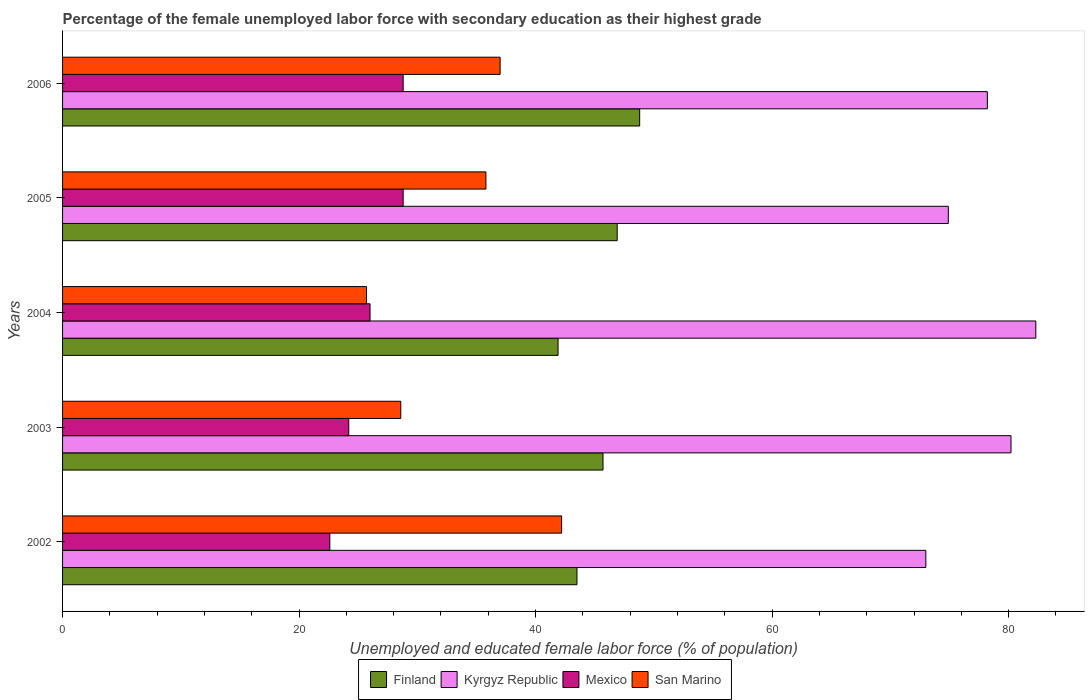How many different coloured bars are there?
Give a very brief answer. 4. How many groups of bars are there?
Offer a terse response. 5. Are the number of bars per tick equal to the number of legend labels?
Ensure brevity in your answer.  Yes. Are the number of bars on each tick of the Y-axis equal?
Provide a succinct answer. Yes. How many bars are there on the 5th tick from the bottom?
Offer a terse response. 4. What is the percentage of the unemployed female labor force with secondary education in Mexico in 2006?
Give a very brief answer. 28.8. Across all years, what is the maximum percentage of the unemployed female labor force with secondary education in San Marino?
Offer a very short reply. 42.2. Across all years, what is the minimum percentage of the unemployed female labor force with secondary education in San Marino?
Provide a short and direct response. 25.7. In which year was the percentage of the unemployed female labor force with secondary education in Finland minimum?
Keep it short and to the point. 2004. What is the total percentage of the unemployed female labor force with secondary education in Kyrgyz Republic in the graph?
Give a very brief answer. 388.6. What is the difference between the percentage of the unemployed female labor force with secondary education in Kyrgyz Republic in 2002 and that in 2005?
Your answer should be very brief. -1.9. What is the difference between the percentage of the unemployed female labor force with secondary education in Mexico in 2004 and the percentage of the unemployed female labor force with secondary education in San Marino in 2005?
Make the answer very short. -9.8. What is the average percentage of the unemployed female labor force with secondary education in Mexico per year?
Keep it short and to the point. 26.08. In the year 2004, what is the difference between the percentage of the unemployed female labor force with secondary education in Mexico and percentage of the unemployed female labor force with secondary education in San Marino?
Provide a succinct answer. 0.3. What is the ratio of the percentage of the unemployed female labor force with secondary education in Mexico in 2004 to that in 2005?
Offer a terse response. 0.9. Is the difference between the percentage of the unemployed female labor force with secondary education in Mexico in 2004 and 2006 greater than the difference between the percentage of the unemployed female labor force with secondary education in San Marino in 2004 and 2006?
Offer a terse response. Yes. What is the difference between the highest and the lowest percentage of the unemployed female labor force with secondary education in Mexico?
Provide a short and direct response. 6.2. In how many years, is the percentage of the unemployed female labor force with secondary education in Kyrgyz Republic greater than the average percentage of the unemployed female labor force with secondary education in Kyrgyz Republic taken over all years?
Ensure brevity in your answer.  3. Is it the case that in every year, the sum of the percentage of the unemployed female labor force with secondary education in Kyrgyz Republic and percentage of the unemployed female labor force with secondary education in San Marino is greater than the sum of percentage of the unemployed female labor force with secondary education in Mexico and percentage of the unemployed female labor force with secondary education in Finland?
Offer a terse response. Yes. What does the 3rd bar from the top in 2003 represents?
Keep it short and to the point. Kyrgyz Republic. What does the 3rd bar from the bottom in 2002 represents?
Provide a succinct answer. Mexico. How many bars are there?
Ensure brevity in your answer.  20. How many years are there in the graph?
Provide a succinct answer. 5. Are the values on the major ticks of X-axis written in scientific E-notation?
Offer a very short reply. No. Does the graph contain any zero values?
Offer a terse response. No. Does the graph contain grids?
Offer a very short reply. No. How many legend labels are there?
Ensure brevity in your answer.  4. How are the legend labels stacked?
Make the answer very short. Horizontal. What is the title of the graph?
Your answer should be compact. Percentage of the female unemployed labor force with secondary education as their highest grade. Does "Bermuda" appear as one of the legend labels in the graph?
Make the answer very short. No. What is the label or title of the X-axis?
Offer a terse response. Unemployed and educated female labor force (% of population). What is the label or title of the Y-axis?
Keep it short and to the point. Years. What is the Unemployed and educated female labor force (% of population) of Finland in 2002?
Provide a short and direct response. 43.5. What is the Unemployed and educated female labor force (% of population) in Kyrgyz Republic in 2002?
Ensure brevity in your answer.  73. What is the Unemployed and educated female labor force (% of population) in Mexico in 2002?
Ensure brevity in your answer.  22.6. What is the Unemployed and educated female labor force (% of population) of San Marino in 2002?
Make the answer very short. 42.2. What is the Unemployed and educated female labor force (% of population) in Finland in 2003?
Provide a short and direct response. 45.7. What is the Unemployed and educated female labor force (% of population) in Kyrgyz Republic in 2003?
Give a very brief answer. 80.2. What is the Unemployed and educated female labor force (% of population) in Mexico in 2003?
Make the answer very short. 24.2. What is the Unemployed and educated female labor force (% of population) in San Marino in 2003?
Offer a very short reply. 28.6. What is the Unemployed and educated female labor force (% of population) of Finland in 2004?
Your answer should be compact. 41.9. What is the Unemployed and educated female labor force (% of population) in Kyrgyz Republic in 2004?
Offer a very short reply. 82.3. What is the Unemployed and educated female labor force (% of population) of San Marino in 2004?
Give a very brief answer. 25.7. What is the Unemployed and educated female labor force (% of population) in Finland in 2005?
Give a very brief answer. 46.9. What is the Unemployed and educated female labor force (% of population) in Kyrgyz Republic in 2005?
Your answer should be compact. 74.9. What is the Unemployed and educated female labor force (% of population) of Mexico in 2005?
Your answer should be compact. 28.8. What is the Unemployed and educated female labor force (% of population) in San Marino in 2005?
Make the answer very short. 35.8. What is the Unemployed and educated female labor force (% of population) in Finland in 2006?
Your answer should be compact. 48.8. What is the Unemployed and educated female labor force (% of population) in Kyrgyz Republic in 2006?
Give a very brief answer. 78.2. What is the Unemployed and educated female labor force (% of population) of Mexico in 2006?
Make the answer very short. 28.8. What is the Unemployed and educated female labor force (% of population) in San Marino in 2006?
Your answer should be very brief. 37. Across all years, what is the maximum Unemployed and educated female labor force (% of population) of Finland?
Your response must be concise. 48.8. Across all years, what is the maximum Unemployed and educated female labor force (% of population) of Kyrgyz Republic?
Your answer should be compact. 82.3. Across all years, what is the maximum Unemployed and educated female labor force (% of population) of Mexico?
Offer a terse response. 28.8. Across all years, what is the maximum Unemployed and educated female labor force (% of population) in San Marino?
Your answer should be compact. 42.2. Across all years, what is the minimum Unemployed and educated female labor force (% of population) in Finland?
Make the answer very short. 41.9. Across all years, what is the minimum Unemployed and educated female labor force (% of population) of Kyrgyz Republic?
Provide a succinct answer. 73. Across all years, what is the minimum Unemployed and educated female labor force (% of population) in Mexico?
Offer a terse response. 22.6. Across all years, what is the minimum Unemployed and educated female labor force (% of population) of San Marino?
Provide a short and direct response. 25.7. What is the total Unemployed and educated female labor force (% of population) in Finland in the graph?
Give a very brief answer. 226.8. What is the total Unemployed and educated female labor force (% of population) of Kyrgyz Republic in the graph?
Make the answer very short. 388.6. What is the total Unemployed and educated female labor force (% of population) of Mexico in the graph?
Your answer should be very brief. 130.4. What is the total Unemployed and educated female labor force (% of population) in San Marino in the graph?
Keep it short and to the point. 169.3. What is the difference between the Unemployed and educated female labor force (% of population) in Finland in 2002 and that in 2003?
Provide a succinct answer. -2.2. What is the difference between the Unemployed and educated female labor force (% of population) of Kyrgyz Republic in 2002 and that in 2003?
Keep it short and to the point. -7.2. What is the difference between the Unemployed and educated female labor force (% of population) in Mexico in 2002 and that in 2003?
Offer a very short reply. -1.6. What is the difference between the Unemployed and educated female labor force (% of population) of Finland in 2002 and that in 2004?
Your response must be concise. 1.6. What is the difference between the Unemployed and educated female labor force (% of population) of San Marino in 2002 and that in 2004?
Offer a very short reply. 16.5. What is the difference between the Unemployed and educated female labor force (% of population) of Finland in 2002 and that in 2005?
Keep it short and to the point. -3.4. What is the difference between the Unemployed and educated female labor force (% of population) of Kyrgyz Republic in 2002 and that in 2005?
Offer a very short reply. -1.9. What is the difference between the Unemployed and educated female labor force (% of population) in Mexico in 2002 and that in 2005?
Give a very brief answer. -6.2. What is the difference between the Unemployed and educated female labor force (% of population) of San Marino in 2002 and that in 2005?
Give a very brief answer. 6.4. What is the difference between the Unemployed and educated female labor force (% of population) in Finland in 2002 and that in 2006?
Provide a succinct answer. -5.3. What is the difference between the Unemployed and educated female labor force (% of population) of Kyrgyz Republic in 2002 and that in 2006?
Offer a very short reply. -5.2. What is the difference between the Unemployed and educated female labor force (% of population) in San Marino in 2002 and that in 2006?
Your response must be concise. 5.2. What is the difference between the Unemployed and educated female labor force (% of population) in Finland in 2003 and that in 2005?
Provide a short and direct response. -1.2. What is the difference between the Unemployed and educated female labor force (% of population) in Mexico in 2003 and that in 2005?
Provide a short and direct response. -4.6. What is the difference between the Unemployed and educated female labor force (% of population) of Mexico in 2003 and that in 2006?
Make the answer very short. -4.6. What is the difference between the Unemployed and educated female labor force (% of population) in Finland in 2004 and that in 2005?
Provide a succinct answer. -5. What is the difference between the Unemployed and educated female labor force (% of population) of Kyrgyz Republic in 2004 and that in 2005?
Your response must be concise. 7.4. What is the difference between the Unemployed and educated female labor force (% of population) in Finland in 2004 and that in 2006?
Your answer should be very brief. -6.9. What is the difference between the Unemployed and educated female labor force (% of population) of Kyrgyz Republic in 2004 and that in 2006?
Your response must be concise. 4.1. What is the difference between the Unemployed and educated female labor force (% of population) of Mexico in 2004 and that in 2006?
Make the answer very short. -2.8. What is the difference between the Unemployed and educated female labor force (% of population) of San Marino in 2004 and that in 2006?
Provide a succinct answer. -11.3. What is the difference between the Unemployed and educated female labor force (% of population) in Kyrgyz Republic in 2005 and that in 2006?
Offer a very short reply. -3.3. What is the difference between the Unemployed and educated female labor force (% of population) of Mexico in 2005 and that in 2006?
Your answer should be very brief. 0. What is the difference between the Unemployed and educated female labor force (% of population) of Finland in 2002 and the Unemployed and educated female labor force (% of population) of Kyrgyz Republic in 2003?
Offer a terse response. -36.7. What is the difference between the Unemployed and educated female labor force (% of population) in Finland in 2002 and the Unemployed and educated female labor force (% of population) in Mexico in 2003?
Make the answer very short. 19.3. What is the difference between the Unemployed and educated female labor force (% of population) of Kyrgyz Republic in 2002 and the Unemployed and educated female labor force (% of population) of Mexico in 2003?
Keep it short and to the point. 48.8. What is the difference between the Unemployed and educated female labor force (% of population) of Kyrgyz Republic in 2002 and the Unemployed and educated female labor force (% of population) of San Marino in 2003?
Your answer should be compact. 44.4. What is the difference between the Unemployed and educated female labor force (% of population) of Mexico in 2002 and the Unemployed and educated female labor force (% of population) of San Marino in 2003?
Provide a succinct answer. -6. What is the difference between the Unemployed and educated female labor force (% of population) of Finland in 2002 and the Unemployed and educated female labor force (% of population) of Kyrgyz Republic in 2004?
Your answer should be compact. -38.8. What is the difference between the Unemployed and educated female labor force (% of population) of Finland in 2002 and the Unemployed and educated female labor force (% of population) of Mexico in 2004?
Provide a short and direct response. 17.5. What is the difference between the Unemployed and educated female labor force (% of population) of Finland in 2002 and the Unemployed and educated female labor force (% of population) of San Marino in 2004?
Keep it short and to the point. 17.8. What is the difference between the Unemployed and educated female labor force (% of population) in Kyrgyz Republic in 2002 and the Unemployed and educated female labor force (% of population) in San Marino in 2004?
Your answer should be compact. 47.3. What is the difference between the Unemployed and educated female labor force (% of population) in Mexico in 2002 and the Unemployed and educated female labor force (% of population) in San Marino in 2004?
Your answer should be compact. -3.1. What is the difference between the Unemployed and educated female labor force (% of population) of Finland in 2002 and the Unemployed and educated female labor force (% of population) of Kyrgyz Republic in 2005?
Offer a terse response. -31.4. What is the difference between the Unemployed and educated female labor force (% of population) of Finland in 2002 and the Unemployed and educated female labor force (% of population) of Mexico in 2005?
Provide a short and direct response. 14.7. What is the difference between the Unemployed and educated female labor force (% of population) in Kyrgyz Republic in 2002 and the Unemployed and educated female labor force (% of population) in Mexico in 2005?
Offer a terse response. 44.2. What is the difference between the Unemployed and educated female labor force (% of population) in Kyrgyz Republic in 2002 and the Unemployed and educated female labor force (% of population) in San Marino in 2005?
Provide a succinct answer. 37.2. What is the difference between the Unemployed and educated female labor force (% of population) in Finland in 2002 and the Unemployed and educated female labor force (% of population) in Kyrgyz Republic in 2006?
Make the answer very short. -34.7. What is the difference between the Unemployed and educated female labor force (% of population) in Finland in 2002 and the Unemployed and educated female labor force (% of population) in Mexico in 2006?
Give a very brief answer. 14.7. What is the difference between the Unemployed and educated female labor force (% of population) of Finland in 2002 and the Unemployed and educated female labor force (% of population) of San Marino in 2006?
Give a very brief answer. 6.5. What is the difference between the Unemployed and educated female labor force (% of population) of Kyrgyz Republic in 2002 and the Unemployed and educated female labor force (% of population) of Mexico in 2006?
Offer a very short reply. 44.2. What is the difference between the Unemployed and educated female labor force (% of population) of Kyrgyz Republic in 2002 and the Unemployed and educated female labor force (% of population) of San Marino in 2006?
Offer a very short reply. 36. What is the difference between the Unemployed and educated female labor force (% of population) of Mexico in 2002 and the Unemployed and educated female labor force (% of population) of San Marino in 2006?
Your response must be concise. -14.4. What is the difference between the Unemployed and educated female labor force (% of population) of Finland in 2003 and the Unemployed and educated female labor force (% of population) of Kyrgyz Republic in 2004?
Offer a terse response. -36.6. What is the difference between the Unemployed and educated female labor force (% of population) of Finland in 2003 and the Unemployed and educated female labor force (% of population) of San Marino in 2004?
Make the answer very short. 20. What is the difference between the Unemployed and educated female labor force (% of population) in Kyrgyz Republic in 2003 and the Unemployed and educated female labor force (% of population) in Mexico in 2004?
Keep it short and to the point. 54.2. What is the difference between the Unemployed and educated female labor force (% of population) of Kyrgyz Republic in 2003 and the Unemployed and educated female labor force (% of population) of San Marino in 2004?
Your answer should be compact. 54.5. What is the difference between the Unemployed and educated female labor force (% of population) in Mexico in 2003 and the Unemployed and educated female labor force (% of population) in San Marino in 2004?
Offer a very short reply. -1.5. What is the difference between the Unemployed and educated female labor force (% of population) in Finland in 2003 and the Unemployed and educated female labor force (% of population) in Kyrgyz Republic in 2005?
Provide a succinct answer. -29.2. What is the difference between the Unemployed and educated female labor force (% of population) of Finland in 2003 and the Unemployed and educated female labor force (% of population) of San Marino in 2005?
Make the answer very short. 9.9. What is the difference between the Unemployed and educated female labor force (% of population) in Kyrgyz Republic in 2003 and the Unemployed and educated female labor force (% of population) in Mexico in 2005?
Your answer should be very brief. 51.4. What is the difference between the Unemployed and educated female labor force (% of population) of Kyrgyz Republic in 2003 and the Unemployed and educated female labor force (% of population) of San Marino in 2005?
Offer a terse response. 44.4. What is the difference between the Unemployed and educated female labor force (% of population) of Finland in 2003 and the Unemployed and educated female labor force (% of population) of Kyrgyz Republic in 2006?
Provide a short and direct response. -32.5. What is the difference between the Unemployed and educated female labor force (% of population) of Finland in 2003 and the Unemployed and educated female labor force (% of population) of Mexico in 2006?
Ensure brevity in your answer.  16.9. What is the difference between the Unemployed and educated female labor force (% of population) in Kyrgyz Republic in 2003 and the Unemployed and educated female labor force (% of population) in Mexico in 2006?
Keep it short and to the point. 51.4. What is the difference between the Unemployed and educated female labor force (% of population) in Kyrgyz Republic in 2003 and the Unemployed and educated female labor force (% of population) in San Marino in 2006?
Keep it short and to the point. 43.2. What is the difference between the Unemployed and educated female labor force (% of population) in Mexico in 2003 and the Unemployed and educated female labor force (% of population) in San Marino in 2006?
Ensure brevity in your answer.  -12.8. What is the difference between the Unemployed and educated female labor force (% of population) of Finland in 2004 and the Unemployed and educated female labor force (% of population) of Kyrgyz Republic in 2005?
Give a very brief answer. -33. What is the difference between the Unemployed and educated female labor force (% of population) of Finland in 2004 and the Unemployed and educated female labor force (% of population) of San Marino in 2005?
Provide a short and direct response. 6.1. What is the difference between the Unemployed and educated female labor force (% of population) in Kyrgyz Republic in 2004 and the Unemployed and educated female labor force (% of population) in Mexico in 2005?
Offer a terse response. 53.5. What is the difference between the Unemployed and educated female labor force (% of population) of Kyrgyz Republic in 2004 and the Unemployed and educated female labor force (% of population) of San Marino in 2005?
Provide a succinct answer. 46.5. What is the difference between the Unemployed and educated female labor force (% of population) in Finland in 2004 and the Unemployed and educated female labor force (% of population) in Kyrgyz Republic in 2006?
Ensure brevity in your answer.  -36.3. What is the difference between the Unemployed and educated female labor force (% of population) in Kyrgyz Republic in 2004 and the Unemployed and educated female labor force (% of population) in Mexico in 2006?
Provide a short and direct response. 53.5. What is the difference between the Unemployed and educated female labor force (% of population) of Kyrgyz Republic in 2004 and the Unemployed and educated female labor force (% of population) of San Marino in 2006?
Give a very brief answer. 45.3. What is the difference between the Unemployed and educated female labor force (% of population) of Mexico in 2004 and the Unemployed and educated female labor force (% of population) of San Marino in 2006?
Your response must be concise. -11. What is the difference between the Unemployed and educated female labor force (% of population) of Finland in 2005 and the Unemployed and educated female labor force (% of population) of Kyrgyz Republic in 2006?
Keep it short and to the point. -31.3. What is the difference between the Unemployed and educated female labor force (% of population) of Finland in 2005 and the Unemployed and educated female labor force (% of population) of Mexico in 2006?
Make the answer very short. 18.1. What is the difference between the Unemployed and educated female labor force (% of population) of Finland in 2005 and the Unemployed and educated female labor force (% of population) of San Marino in 2006?
Offer a very short reply. 9.9. What is the difference between the Unemployed and educated female labor force (% of population) in Kyrgyz Republic in 2005 and the Unemployed and educated female labor force (% of population) in Mexico in 2006?
Provide a succinct answer. 46.1. What is the difference between the Unemployed and educated female labor force (% of population) in Kyrgyz Republic in 2005 and the Unemployed and educated female labor force (% of population) in San Marino in 2006?
Give a very brief answer. 37.9. What is the average Unemployed and educated female labor force (% of population) of Finland per year?
Your answer should be compact. 45.36. What is the average Unemployed and educated female labor force (% of population) in Kyrgyz Republic per year?
Your answer should be very brief. 77.72. What is the average Unemployed and educated female labor force (% of population) of Mexico per year?
Offer a very short reply. 26.08. What is the average Unemployed and educated female labor force (% of population) of San Marino per year?
Ensure brevity in your answer.  33.86. In the year 2002, what is the difference between the Unemployed and educated female labor force (% of population) of Finland and Unemployed and educated female labor force (% of population) of Kyrgyz Republic?
Your response must be concise. -29.5. In the year 2002, what is the difference between the Unemployed and educated female labor force (% of population) in Finland and Unemployed and educated female labor force (% of population) in Mexico?
Provide a short and direct response. 20.9. In the year 2002, what is the difference between the Unemployed and educated female labor force (% of population) of Finland and Unemployed and educated female labor force (% of population) of San Marino?
Your answer should be very brief. 1.3. In the year 2002, what is the difference between the Unemployed and educated female labor force (% of population) in Kyrgyz Republic and Unemployed and educated female labor force (% of population) in Mexico?
Your response must be concise. 50.4. In the year 2002, what is the difference between the Unemployed and educated female labor force (% of population) of Kyrgyz Republic and Unemployed and educated female labor force (% of population) of San Marino?
Give a very brief answer. 30.8. In the year 2002, what is the difference between the Unemployed and educated female labor force (% of population) of Mexico and Unemployed and educated female labor force (% of population) of San Marino?
Your response must be concise. -19.6. In the year 2003, what is the difference between the Unemployed and educated female labor force (% of population) in Finland and Unemployed and educated female labor force (% of population) in Kyrgyz Republic?
Provide a succinct answer. -34.5. In the year 2003, what is the difference between the Unemployed and educated female labor force (% of population) in Kyrgyz Republic and Unemployed and educated female labor force (% of population) in San Marino?
Provide a short and direct response. 51.6. In the year 2003, what is the difference between the Unemployed and educated female labor force (% of population) of Mexico and Unemployed and educated female labor force (% of population) of San Marino?
Your answer should be compact. -4.4. In the year 2004, what is the difference between the Unemployed and educated female labor force (% of population) in Finland and Unemployed and educated female labor force (% of population) in Kyrgyz Republic?
Your answer should be very brief. -40.4. In the year 2004, what is the difference between the Unemployed and educated female labor force (% of population) of Finland and Unemployed and educated female labor force (% of population) of Mexico?
Give a very brief answer. 15.9. In the year 2004, what is the difference between the Unemployed and educated female labor force (% of population) of Kyrgyz Republic and Unemployed and educated female labor force (% of population) of Mexico?
Provide a succinct answer. 56.3. In the year 2004, what is the difference between the Unemployed and educated female labor force (% of population) of Kyrgyz Republic and Unemployed and educated female labor force (% of population) of San Marino?
Your answer should be very brief. 56.6. In the year 2005, what is the difference between the Unemployed and educated female labor force (% of population) in Kyrgyz Republic and Unemployed and educated female labor force (% of population) in Mexico?
Keep it short and to the point. 46.1. In the year 2005, what is the difference between the Unemployed and educated female labor force (% of population) in Kyrgyz Republic and Unemployed and educated female labor force (% of population) in San Marino?
Give a very brief answer. 39.1. In the year 2006, what is the difference between the Unemployed and educated female labor force (% of population) in Finland and Unemployed and educated female labor force (% of population) in Kyrgyz Republic?
Make the answer very short. -29.4. In the year 2006, what is the difference between the Unemployed and educated female labor force (% of population) in Kyrgyz Republic and Unemployed and educated female labor force (% of population) in Mexico?
Offer a terse response. 49.4. In the year 2006, what is the difference between the Unemployed and educated female labor force (% of population) in Kyrgyz Republic and Unemployed and educated female labor force (% of population) in San Marino?
Your answer should be very brief. 41.2. In the year 2006, what is the difference between the Unemployed and educated female labor force (% of population) of Mexico and Unemployed and educated female labor force (% of population) of San Marino?
Provide a succinct answer. -8.2. What is the ratio of the Unemployed and educated female labor force (% of population) of Finland in 2002 to that in 2003?
Provide a succinct answer. 0.95. What is the ratio of the Unemployed and educated female labor force (% of population) in Kyrgyz Republic in 2002 to that in 2003?
Your answer should be compact. 0.91. What is the ratio of the Unemployed and educated female labor force (% of population) in Mexico in 2002 to that in 2003?
Your answer should be compact. 0.93. What is the ratio of the Unemployed and educated female labor force (% of population) of San Marino in 2002 to that in 2003?
Provide a succinct answer. 1.48. What is the ratio of the Unemployed and educated female labor force (% of population) in Finland in 2002 to that in 2004?
Offer a very short reply. 1.04. What is the ratio of the Unemployed and educated female labor force (% of population) in Kyrgyz Republic in 2002 to that in 2004?
Your answer should be compact. 0.89. What is the ratio of the Unemployed and educated female labor force (% of population) in Mexico in 2002 to that in 2004?
Your answer should be compact. 0.87. What is the ratio of the Unemployed and educated female labor force (% of population) in San Marino in 2002 to that in 2004?
Offer a terse response. 1.64. What is the ratio of the Unemployed and educated female labor force (% of population) in Finland in 2002 to that in 2005?
Provide a succinct answer. 0.93. What is the ratio of the Unemployed and educated female labor force (% of population) in Kyrgyz Republic in 2002 to that in 2005?
Your answer should be very brief. 0.97. What is the ratio of the Unemployed and educated female labor force (% of population) in Mexico in 2002 to that in 2005?
Your response must be concise. 0.78. What is the ratio of the Unemployed and educated female labor force (% of population) in San Marino in 2002 to that in 2005?
Ensure brevity in your answer.  1.18. What is the ratio of the Unemployed and educated female labor force (% of population) of Finland in 2002 to that in 2006?
Your answer should be very brief. 0.89. What is the ratio of the Unemployed and educated female labor force (% of population) in Kyrgyz Republic in 2002 to that in 2006?
Provide a short and direct response. 0.93. What is the ratio of the Unemployed and educated female labor force (% of population) in Mexico in 2002 to that in 2006?
Your response must be concise. 0.78. What is the ratio of the Unemployed and educated female labor force (% of population) in San Marino in 2002 to that in 2006?
Keep it short and to the point. 1.14. What is the ratio of the Unemployed and educated female labor force (% of population) in Finland in 2003 to that in 2004?
Ensure brevity in your answer.  1.09. What is the ratio of the Unemployed and educated female labor force (% of population) in Kyrgyz Republic in 2003 to that in 2004?
Give a very brief answer. 0.97. What is the ratio of the Unemployed and educated female labor force (% of population) of Mexico in 2003 to that in 2004?
Make the answer very short. 0.93. What is the ratio of the Unemployed and educated female labor force (% of population) in San Marino in 2003 to that in 2004?
Your answer should be compact. 1.11. What is the ratio of the Unemployed and educated female labor force (% of population) in Finland in 2003 to that in 2005?
Your answer should be very brief. 0.97. What is the ratio of the Unemployed and educated female labor force (% of population) in Kyrgyz Republic in 2003 to that in 2005?
Provide a short and direct response. 1.07. What is the ratio of the Unemployed and educated female labor force (% of population) of Mexico in 2003 to that in 2005?
Provide a short and direct response. 0.84. What is the ratio of the Unemployed and educated female labor force (% of population) in San Marino in 2003 to that in 2005?
Offer a terse response. 0.8. What is the ratio of the Unemployed and educated female labor force (% of population) in Finland in 2003 to that in 2006?
Offer a very short reply. 0.94. What is the ratio of the Unemployed and educated female labor force (% of population) of Kyrgyz Republic in 2003 to that in 2006?
Keep it short and to the point. 1.03. What is the ratio of the Unemployed and educated female labor force (% of population) in Mexico in 2003 to that in 2006?
Ensure brevity in your answer.  0.84. What is the ratio of the Unemployed and educated female labor force (% of population) in San Marino in 2003 to that in 2006?
Give a very brief answer. 0.77. What is the ratio of the Unemployed and educated female labor force (% of population) of Finland in 2004 to that in 2005?
Ensure brevity in your answer.  0.89. What is the ratio of the Unemployed and educated female labor force (% of population) in Kyrgyz Republic in 2004 to that in 2005?
Keep it short and to the point. 1.1. What is the ratio of the Unemployed and educated female labor force (% of population) in Mexico in 2004 to that in 2005?
Offer a terse response. 0.9. What is the ratio of the Unemployed and educated female labor force (% of population) in San Marino in 2004 to that in 2005?
Make the answer very short. 0.72. What is the ratio of the Unemployed and educated female labor force (% of population) of Finland in 2004 to that in 2006?
Offer a terse response. 0.86. What is the ratio of the Unemployed and educated female labor force (% of population) of Kyrgyz Republic in 2004 to that in 2006?
Your answer should be compact. 1.05. What is the ratio of the Unemployed and educated female labor force (% of population) in Mexico in 2004 to that in 2006?
Your answer should be very brief. 0.9. What is the ratio of the Unemployed and educated female labor force (% of population) in San Marino in 2004 to that in 2006?
Keep it short and to the point. 0.69. What is the ratio of the Unemployed and educated female labor force (% of population) in Finland in 2005 to that in 2006?
Keep it short and to the point. 0.96. What is the ratio of the Unemployed and educated female labor force (% of population) in Kyrgyz Republic in 2005 to that in 2006?
Ensure brevity in your answer.  0.96. What is the ratio of the Unemployed and educated female labor force (% of population) in Mexico in 2005 to that in 2006?
Provide a succinct answer. 1. What is the ratio of the Unemployed and educated female labor force (% of population) of San Marino in 2005 to that in 2006?
Offer a terse response. 0.97. What is the difference between the highest and the second highest Unemployed and educated female labor force (% of population) in Finland?
Make the answer very short. 1.9. What is the difference between the highest and the second highest Unemployed and educated female labor force (% of population) in Mexico?
Keep it short and to the point. 0. What is the difference between the highest and the lowest Unemployed and educated female labor force (% of population) in Finland?
Make the answer very short. 6.9. 